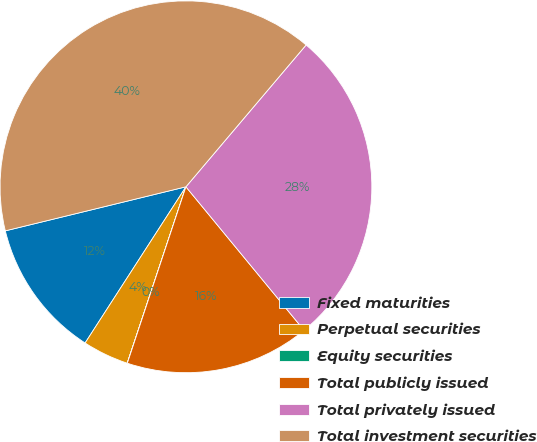<chart> <loc_0><loc_0><loc_500><loc_500><pie_chart><fcel>Fixed maturities<fcel>Perpetual securities<fcel>Equity securities<fcel>Total publicly issued<fcel>Total privately issued<fcel>Total investment securities<nl><fcel>12.07%<fcel>4.01%<fcel>0.01%<fcel>16.07%<fcel>27.85%<fcel>40.0%<nl></chart> 